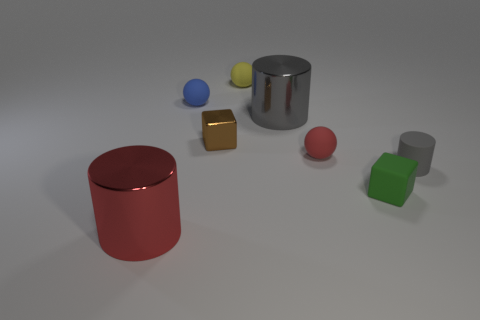There is a rubber thing that is both on the right side of the blue rubber thing and left of the big gray cylinder; how big is it?
Keep it short and to the point. Small. Are there more tiny red blocks than red rubber objects?
Your answer should be compact. No. Are there any rubber spheres of the same color as the small cylinder?
Offer a terse response. No. There is a red object that is behind the gray matte cylinder; is its size the same as the large red metal cylinder?
Your answer should be compact. No. Are there fewer objects than tiny matte cylinders?
Your answer should be compact. No. Is there a large cyan cube that has the same material as the small blue object?
Your response must be concise. No. What shape is the gray metallic object that is behind the small green matte object?
Your answer should be compact. Cylinder. There is a big metal object to the right of the tiny brown block; does it have the same color as the small cylinder?
Ensure brevity in your answer.  Yes. Are there fewer tiny red spheres in front of the red metal cylinder than small yellow matte spheres?
Your response must be concise. Yes. What is the color of the cube that is the same material as the large gray cylinder?
Give a very brief answer. Brown. 